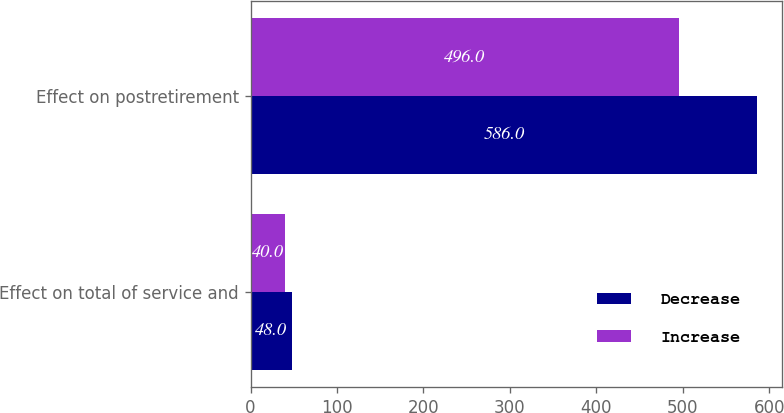<chart> <loc_0><loc_0><loc_500><loc_500><stacked_bar_chart><ecel><fcel>Effect on total of service and<fcel>Effect on postretirement<nl><fcel>Decrease<fcel>48<fcel>586<nl><fcel>Increase<fcel>40<fcel>496<nl></chart> 